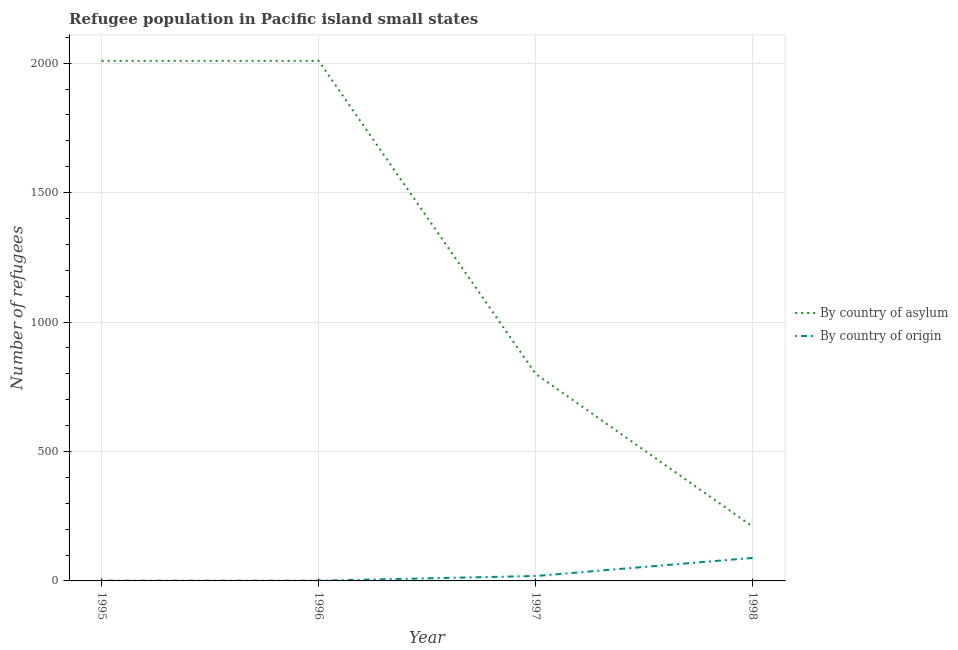Does the line corresponding to number of refugees by country of asylum intersect with the line corresponding to number of refugees by country of origin?
Keep it short and to the point. No. What is the number of refugees by country of asylum in 1998?
Your answer should be very brief. 210. Across all years, what is the maximum number of refugees by country of origin?
Provide a succinct answer. 89. Across all years, what is the minimum number of refugees by country of asylum?
Provide a succinct answer. 210. In which year was the number of refugees by country of asylum maximum?
Your answer should be compact. 1995. What is the total number of refugees by country of origin in the graph?
Offer a very short reply. 110. What is the difference between the number of refugees by country of asylum in 1996 and that in 1998?
Your response must be concise. 1799. What is the difference between the number of refugees by country of asylum in 1997 and the number of refugees by country of origin in 1998?
Provide a succinct answer. 711. In the year 1997, what is the difference between the number of refugees by country of asylum and number of refugees by country of origin?
Provide a short and direct response. 781. What is the ratio of the number of refugees by country of asylum in 1995 to that in 1996?
Make the answer very short. 1. What is the difference between the highest and the lowest number of refugees by country of origin?
Make the answer very short. 88. In how many years, is the number of refugees by country of asylum greater than the average number of refugees by country of asylum taken over all years?
Offer a very short reply. 2. Is the sum of the number of refugees by country of asylum in 1995 and 1996 greater than the maximum number of refugees by country of origin across all years?
Give a very brief answer. Yes. How many lines are there?
Ensure brevity in your answer.  2. How many years are there in the graph?
Your answer should be very brief. 4. What is the difference between two consecutive major ticks on the Y-axis?
Provide a succinct answer. 500. Does the graph contain any zero values?
Offer a terse response. No. Does the graph contain grids?
Offer a terse response. Yes. How are the legend labels stacked?
Your response must be concise. Vertical. What is the title of the graph?
Make the answer very short. Refugee population in Pacific island small states. Does "Rural" appear as one of the legend labels in the graph?
Offer a very short reply. No. What is the label or title of the X-axis?
Keep it short and to the point. Year. What is the label or title of the Y-axis?
Keep it short and to the point. Number of refugees. What is the Number of refugees of By country of asylum in 1995?
Keep it short and to the point. 2009. What is the Number of refugees of By country of asylum in 1996?
Provide a short and direct response. 2009. What is the Number of refugees of By country of origin in 1996?
Make the answer very short. 1. What is the Number of refugees in By country of asylum in 1997?
Make the answer very short. 800. What is the Number of refugees of By country of origin in 1997?
Your answer should be very brief. 19. What is the Number of refugees of By country of asylum in 1998?
Your answer should be compact. 210. What is the Number of refugees of By country of origin in 1998?
Keep it short and to the point. 89. Across all years, what is the maximum Number of refugees of By country of asylum?
Your response must be concise. 2009. Across all years, what is the maximum Number of refugees in By country of origin?
Your answer should be very brief. 89. Across all years, what is the minimum Number of refugees in By country of asylum?
Make the answer very short. 210. What is the total Number of refugees of By country of asylum in the graph?
Your answer should be very brief. 5028. What is the total Number of refugees in By country of origin in the graph?
Offer a very short reply. 110. What is the difference between the Number of refugees of By country of asylum in 1995 and that in 1997?
Provide a short and direct response. 1209. What is the difference between the Number of refugees in By country of asylum in 1995 and that in 1998?
Offer a terse response. 1799. What is the difference between the Number of refugees in By country of origin in 1995 and that in 1998?
Ensure brevity in your answer.  -88. What is the difference between the Number of refugees of By country of asylum in 1996 and that in 1997?
Provide a short and direct response. 1209. What is the difference between the Number of refugees in By country of asylum in 1996 and that in 1998?
Keep it short and to the point. 1799. What is the difference between the Number of refugees of By country of origin in 1996 and that in 1998?
Your response must be concise. -88. What is the difference between the Number of refugees in By country of asylum in 1997 and that in 1998?
Make the answer very short. 590. What is the difference between the Number of refugees in By country of origin in 1997 and that in 1998?
Your answer should be very brief. -70. What is the difference between the Number of refugees of By country of asylum in 1995 and the Number of refugees of By country of origin in 1996?
Ensure brevity in your answer.  2008. What is the difference between the Number of refugees in By country of asylum in 1995 and the Number of refugees in By country of origin in 1997?
Offer a terse response. 1990. What is the difference between the Number of refugees in By country of asylum in 1995 and the Number of refugees in By country of origin in 1998?
Your response must be concise. 1920. What is the difference between the Number of refugees of By country of asylum in 1996 and the Number of refugees of By country of origin in 1997?
Your answer should be very brief. 1990. What is the difference between the Number of refugees of By country of asylum in 1996 and the Number of refugees of By country of origin in 1998?
Keep it short and to the point. 1920. What is the difference between the Number of refugees of By country of asylum in 1997 and the Number of refugees of By country of origin in 1998?
Offer a very short reply. 711. What is the average Number of refugees of By country of asylum per year?
Offer a terse response. 1257. In the year 1995, what is the difference between the Number of refugees in By country of asylum and Number of refugees in By country of origin?
Make the answer very short. 2008. In the year 1996, what is the difference between the Number of refugees of By country of asylum and Number of refugees of By country of origin?
Offer a terse response. 2008. In the year 1997, what is the difference between the Number of refugees in By country of asylum and Number of refugees in By country of origin?
Provide a short and direct response. 781. In the year 1998, what is the difference between the Number of refugees of By country of asylum and Number of refugees of By country of origin?
Make the answer very short. 121. What is the ratio of the Number of refugees of By country of origin in 1995 to that in 1996?
Make the answer very short. 1. What is the ratio of the Number of refugees of By country of asylum in 1995 to that in 1997?
Give a very brief answer. 2.51. What is the ratio of the Number of refugees in By country of origin in 1995 to that in 1997?
Offer a very short reply. 0.05. What is the ratio of the Number of refugees in By country of asylum in 1995 to that in 1998?
Keep it short and to the point. 9.57. What is the ratio of the Number of refugees of By country of origin in 1995 to that in 1998?
Offer a very short reply. 0.01. What is the ratio of the Number of refugees in By country of asylum in 1996 to that in 1997?
Offer a very short reply. 2.51. What is the ratio of the Number of refugees of By country of origin in 1996 to that in 1997?
Make the answer very short. 0.05. What is the ratio of the Number of refugees in By country of asylum in 1996 to that in 1998?
Keep it short and to the point. 9.57. What is the ratio of the Number of refugees in By country of origin in 1996 to that in 1998?
Give a very brief answer. 0.01. What is the ratio of the Number of refugees of By country of asylum in 1997 to that in 1998?
Keep it short and to the point. 3.81. What is the ratio of the Number of refugees in By country of origin in 1997 to that in 1998?
Make the answer very short. 0.21. What is the difference between the highest and the second highest Number of refugees in By country of asylum?
Your answer should be very brief. 0. What is the difference between the highest and the second highest Number of refugees in By country of origin?
Your answer should be compact. 70. What is the difference between the highest and the lowest Number of refugees of By country of asylum?
Provide a short and direct response. 1799. What is the difference between the highest and the lowest Number of refugees of By country of origin?
Provide a succinct answer. 88. 